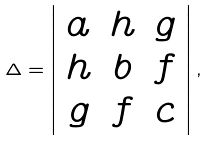Convert formula to latex. <formula><loc_0><loc_0><loc_500><loc_500>\Delta = \left | \begin{array} { c c c } a & h & g \\ h & b & f \\ g & f & c \end{array} \right | ,</formula> 